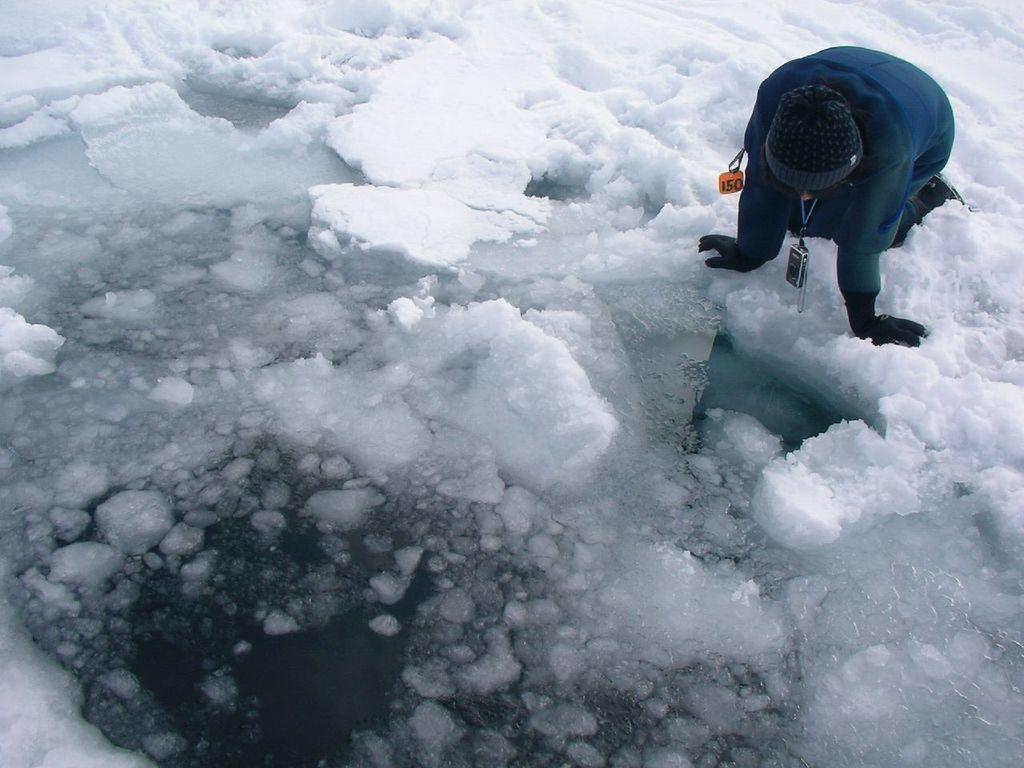What is the main subject in the middle of the image? There is ice in the middle of the image. Can you describe the person in the image? There is a person in the image, and they are kneeling down in the snow. What is the person doing in the image? The person is looking at the ice. How many chairs are visible in the image? There are no chairs present in the image. What word is written on the ice in the image? There is no word written on the ice in the image. 